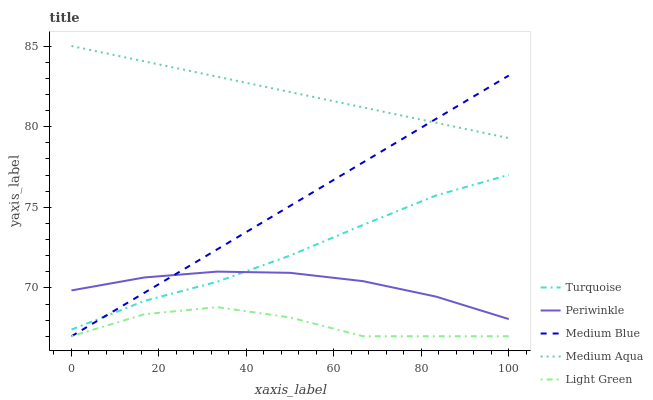Does Light Green have the minimum area under the curve?
Answer yes or no. Yes. Does Medium Aqua have the maximum area under the curve?
Answer yes or no. Yes. Does Medium Blue have the minimum area under the curve?
Answer yes or no. No. Does Medium Blue have the maximum area under the curve?
Answer yes or no. No. Is Medium Aqua the smoothest?
Answer yes or no. Yes. Is Light Green the roughest?
Answer yes or no. Yes. Is Medium Blue the smoothest?
Answer yes or no. No. Is Medium Blue the roughest?
Answer yes or no. No. Does Medium Blue have the lowest value?
Answer yes or no. Yes. Does Turquoise have the lowest value?
Answer yes or no. No. Does Medium Aqua have the highest value?
Answer yes or no. Yes. Does Medium Blue have the highest value?
Answer yes or no. No. Is Light Green less than Turquoise?
Answer yes or no. Yes. Is Periwinkle greater than Light Green?
Answer yes or no. Yes. Does Light Green intersect Medium Blue?
Answer yes or no. Yes. Is Light Green less than Medium Blue?
Answer yes or no. No. Is Light Green greater than Medium Blue?
Answer yes or no. No. Does Light Green intersect Turquoise?
Answer yes or no. No. 